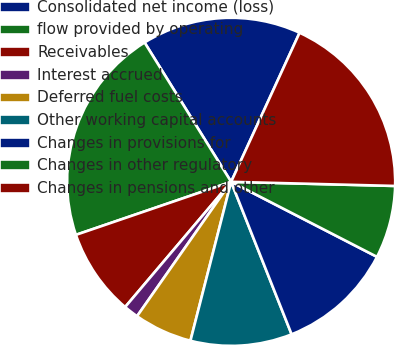<chart> <loc_0><loc_0><loc_500><loc_500><pie_chart><fcel>Consolidated net income (loss)<fcel>flow provided by operating<fcel>Receivables<fcel>Interest accrued<fcel>Deferred fuel costs<fcel>Other working capital accounts<fcel>Changes in provisions for<fcel>Changes in other regulatory<fcel>Changes in pensions and other<nl><fcel>15.7%<fcel>21.39%<fcel>8.58%<fcel>1.46%<fcel>5.73%<fcel>10.0%<fcel>11.43%<fcel>7.16%<fcel>18.55%<nl></chart> 